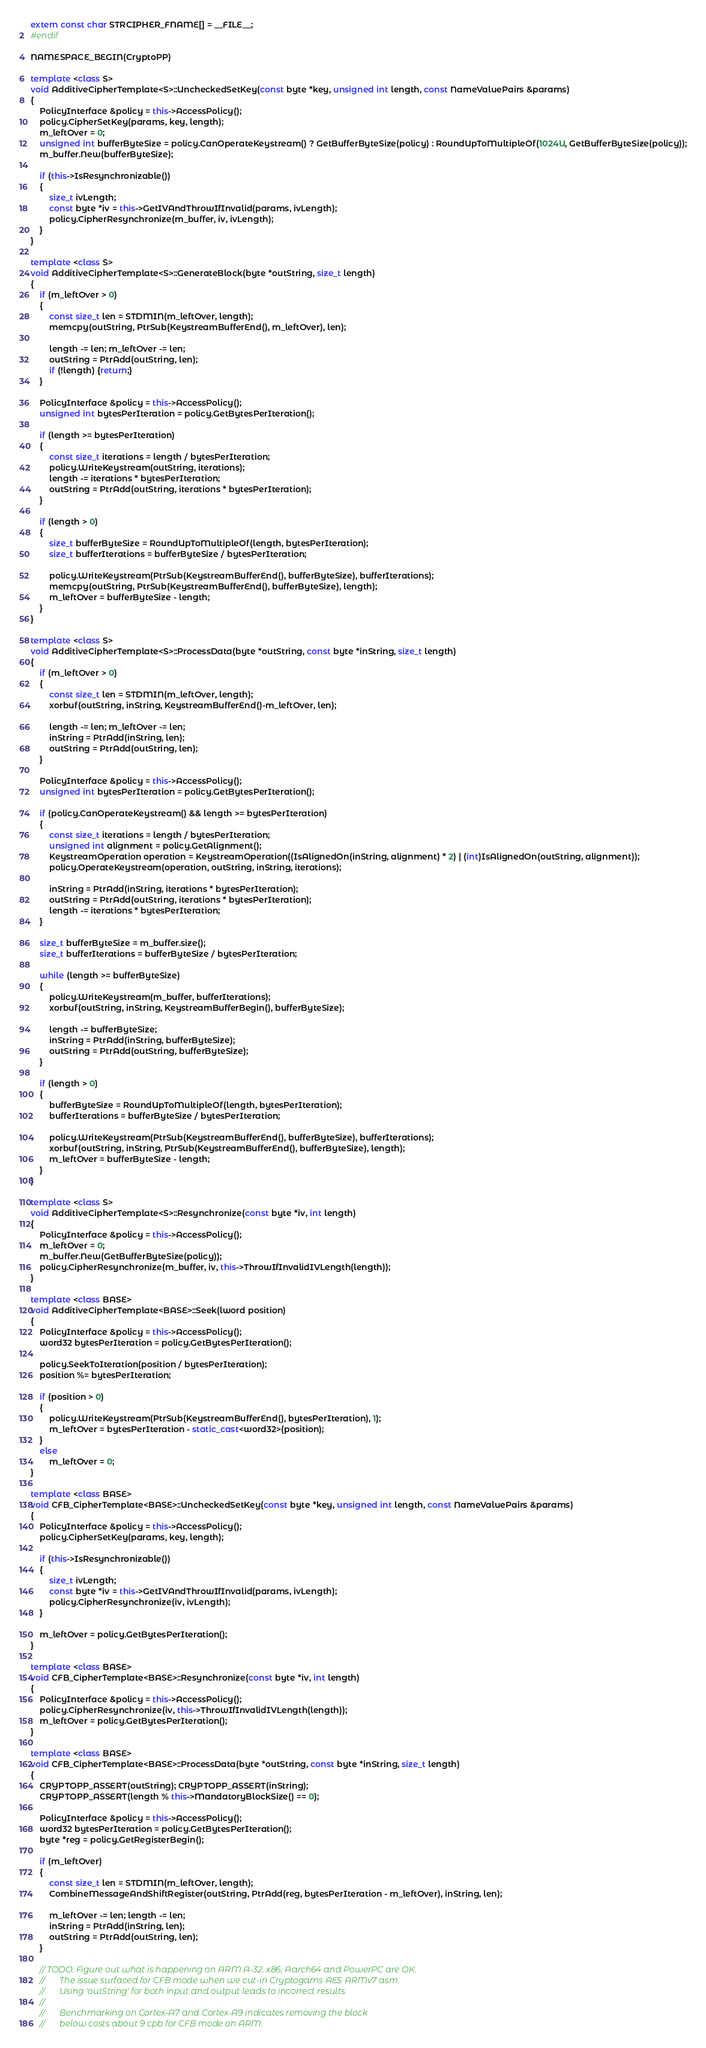<code> <loc_0><loc_0><loc_500><loc_500><_C++_>extern const char STRCIPHER_FNAME[] = __FILE__;
#endif

NAMESPACE_BEGIN(CryptoPP)

template <class S>
void AdditiveCipherTemplate<S>::UncheckedSetKey(const byte *key, unsigned int length, const NameValuePairs &params)
{
	PolicyInterface &policy = this->AccessPolicy();
	policy.CipherSetKey(params, key, length);
	m_leftOver = 0;
	unsigned int bufferByteSize = policy.CanOperateKeystream() ? GetBufferByteSize(policy) : RoundUpToMultipleOf(1024U, GetBufferByteSize(policy));
	m_buffer.New(bufferByteSize);

	if (this->IsResynchronizable())
	{
		size_t ivLength;
		const byte *iv = this->GetIVAndThrowIfInvalid(params, ivLength);
		policy.CipherResynchronize(m_buffer, iv, ivLength);
	}
}

template <class S>
void AdditiveCipherTemplate<S>::GenerateBlock(byte *outString, size_t length)
{
	if (m_leftOver > 0)
	{
		const size_t len = STDMIN(m_leftOver, length);
		memcpy(outString, PtrSub(KeystreamBufferEnd(), m_leftOver), len);

		length -= len; m_leftOver -= len;
		outString = PtrAdd(outString, len);
		if (!length) {return;}
	}

	PolicyInterface &policy = this->AccessPolicy();
	unsigned int bytesPerIteration = policy.GetBytesPerIteration();

	if (length >= bytesPerIteration)
	{
		const size_t iterations = length / bytesPerIteration;
		policy.WriteKeystream(outString, iterations);
		length -= iterations * bytesPerIteration;
		outString = PtrAdd(outString, iterations * bytesPerIteration);
	}

	if (length > 0)
	{
		size_t bufferByteSize = RoundUpToMultipleOf(length, bytesPerIteration);
		size_t bufferIterations = bufferByteSize / bytesPerIteration;

		policy.WriteKeystream(PtrSub(KeystreamBufferEnd(), bufferByteSize), bufferIterations);
		memcpy(outString, PtrSub(KeystreamBufferEnd(), bufferByteSize), length);
		m_leftOver = bufferByteSize - length;
	}
}

template <class S>
void AdditiveCipherTemplate<S>::ProcessData(byte *outString, const byte *inString, size_t length)
{
	if (m_leftOver > 0)
	{
		const size_t len = STDMIN(m_leftOver, length);
		xorbuf(outString, inString, KeystreamBufferEnd()-m_leftOver, len);

		length -= len; m_leftOver -= len;
		inString = PtrAdd(inString, len);
		outString = PtrAdd(outString, len);
	}

	PolicyInterface &policy = this->AccessPolicy();
	unsigned int bytesPerIteration = policy.GetBytesPerIteration();

	if (policy.CanOperateKeystream() && length >= bytesPerIteration)
	{
		const size_t iterations = length / bytesPerIteration;
		unsigned int alignment = policy.GetAlignment();
		KeystreamOperation operation = KeystreamOperation((IsAlignedOn(inString, alignment) * 2) | (int)IsAlignedOn(outString, alignment));
		policy.OperateKeystream(operation, outString, inString, iterations);

		inString = PtrAdd(inString, iterations * bytesPerIteration);
		outString = PtrAdd(outString, iterations * bytesPerIteration);
		length -= iterations * bytesPerIteration;
	}

	size_t bufferByteSize = m_buffer.size();
	size_t bufferIterations = bufferByteSize / bytesPerIteration;

	while (length >= bufferByteSize)
	{
		policy.WriteKeystream(m_buffer, bufferIterations);
		xorbuf(outString, inString, KeystreamBufferBegin(), bufferByteSize);

		length -= bufferByteSize;
		inString = PtrAdd(inString, bufferByteSize);
		outString = PtrAdd(outString, bufferByteSize);
	}

	if (length > 0)
	{
		bufferByteSize = RoundUpToMultipleOf(length, bytesPerIteration);
		bufferIterations = bufferByteSize / bytesPerIteration;

		policy.WriteKeystream(PtrSub(KeystreamBufferEnd(), bufferByteSize), bufferIterations);
		xorbuf(outString, inString, PtrSub(KeystreamBufferEnd(), bufferByteSize), length);
		m_leftOver = bufferByteSize - length;
	}
}

template <class S>
void AdditiveCipherTemplate<S>::Resynchronize(const byte *iv, int length)
{
	PolicyInterface &policy = this->AccessPolicy();
	m_leftOver = 0;
	m_buffer.New(GetBufferByteSize(policy));
	policy.CipherResynchronize(m_buffer, iv, this->ThrowIfInvalidIVLength(length));
}

template <class BASE>
void AdditiveCipherTemplate<BASE>::Seek(lword position)
{
	PolicyInterface &policy = this->AccessPolicy();
	word32 bytesPerIteration = policy.GetBytesPerIteration();

	policy.SeekToIteration(position / bytesPerIteration);
	position %= bytesPerIteration;

	if (position > 0)
	{
		policy.WriteKeystream(PtrSub(KeystreamBufferEnd(), bytesPerIteration), 1);
		m_leftOver = bytesPerIteration - static_cast<word32>(position);
	}
	else
		m_leftOver = 0;
}

template <class BASE>
void CFB_CipherTemplate<BASE>::UncheckedSetKey(const byte *key, unsigned int length, const NameValuePairs &params)
{
	PolicyInterface &policy = this->AccessPolicy();
	policy.CipherSetKey(params, key, length);

	if (this->IsResynchronizable())
	{
		size_t ivLength;
		const byte *iv = this->GetIVAndThrowIfInvalid(params, ivLength);
		policy.CipherResynchronize(iv, ivLength);
	}

	m_leftOver = policy.GetBytesPerIteration();
}

template <class BASE>
void CFB_CipherTemplate<BASE>::Resynchronize(const byte *iv, int length)
{
	PolicyInterface &policy = this->AccessPolicy();
	policy.CipherResynchronize(iv, this->ThrowIfInvalidIVLength(length));
	m_leftOver = policy.GetBytesPerIteration();
}

template <class BASE>
void CFB_CipherTemplate<BASE>::ProcessData(byte *outString, const byte *inString, size_t length)
{
	CRYPTOPP_ASSERT(outString); CRYPTOPP_ASSERT(inString);
	CRYPTOPP_ASSERT(length % this->MandatoryBlockSize() == 0);

	PolicyInterface &policy = this->AccessPolicy();
	word32 bytesPerIteration = policy.GetBytesPerIteration();
	byte *reg = policy.GetRegisterBegin();

	if (m_leftOver)
	{
		const size_t len = STDMIN(m_leftOver, length);
		CombineMessageAndShiftRegister(outString, PtrAdd(reg, bytesPerIteration - m_leftOver), inString, len);

		m_leftOver -= len; length -= len;
		inString = PtrAdd(inString, len);
		outString = PtrAdd(outString, len);
	}

	// TODO: Figure out what is happening on ARM A-32. x86, Aarch64 and PowerPC are OK.
	//       The issue surfaced for CFB mode when we cut-in Cryptogams AES ARMv7 asm.
	//       Using 'outString' for both input and output leads to incorrect results.
	//
	//       Benchmarking on Cortex-A7 and Cortex-A9 indicates removing the block
	//       below costs about 9 cpb for CFB mode on ARM.</code> 